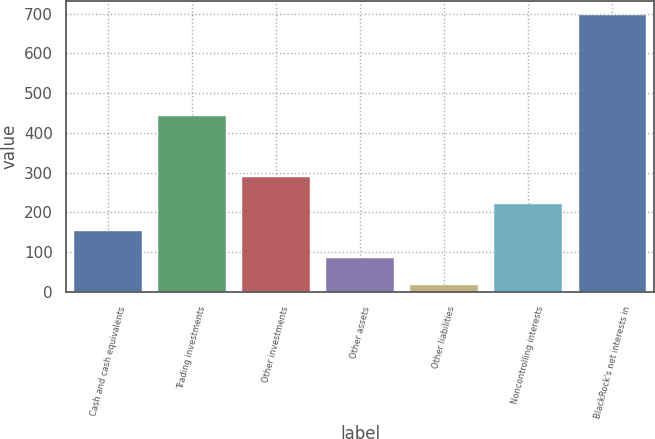Convert chart. <chart><loc_0><loc_0><loc_500><loc_500><bar_chart><fcel>Cash and cash equivalents<fcel>Trading investments<fcel>Other investments<fcel>Other assets<fcel>Other liabilities<fcel>Noncontrolling interests<fcel>BlackRock's net interests in<nl><fcel>153.6<fcel>443<fcel>289.2<fcel>85.8<fcel>18<fcel>221.4<fcel>696<nl></chart> 